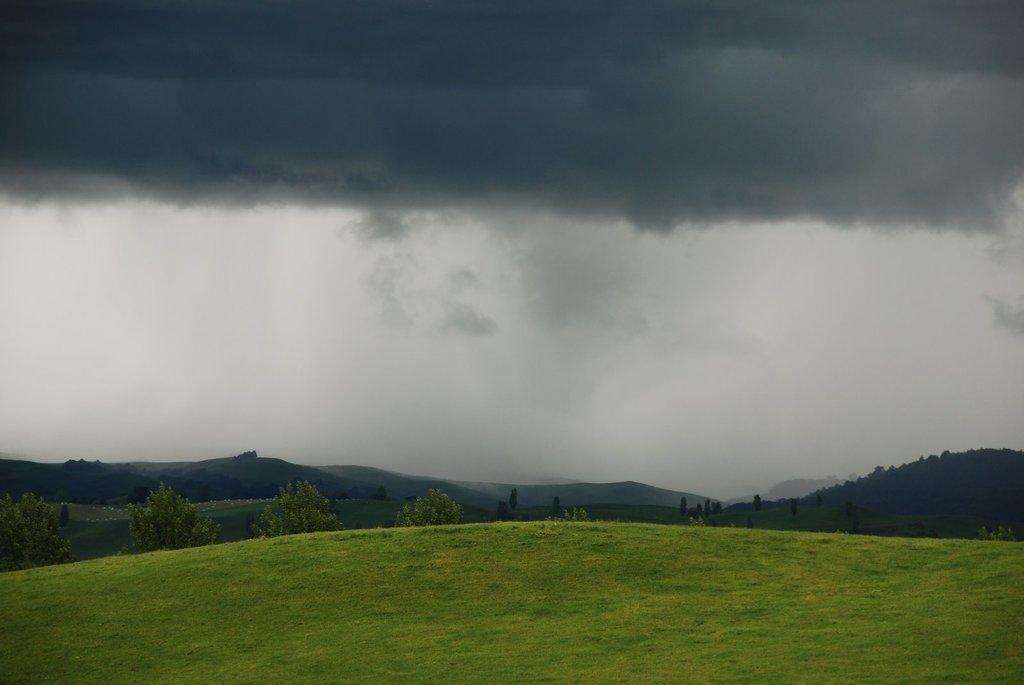Could you give a brief overview of what you see in this image? In this image we can see sky with clouds, hills, trees and ground. 